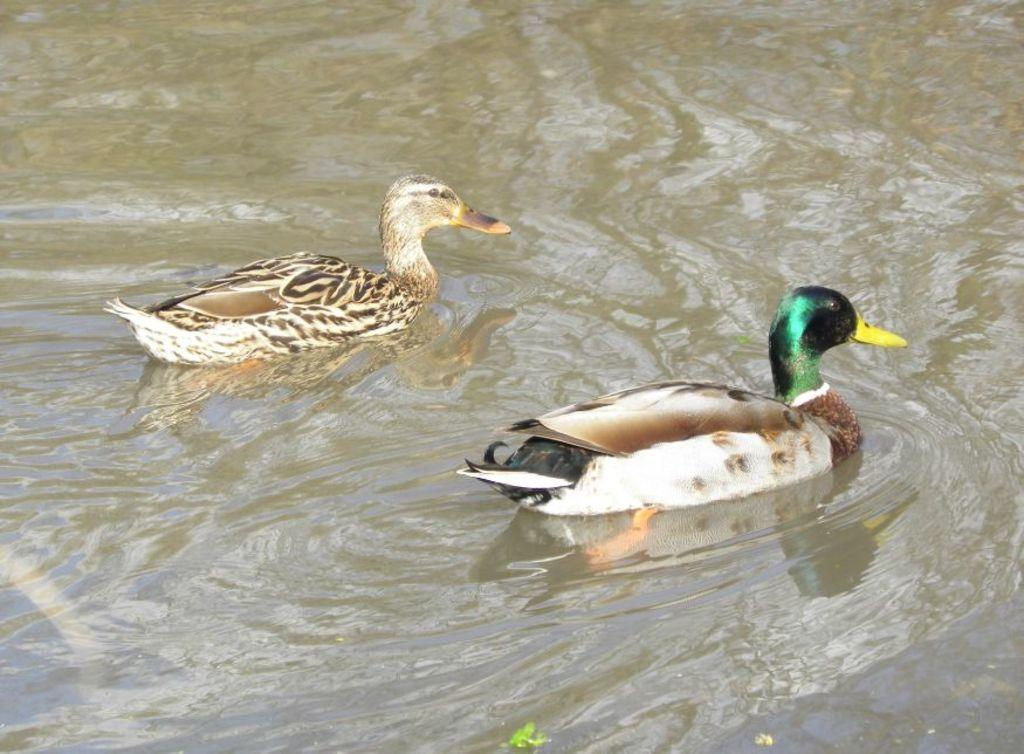What type of animals can be seen in the image? There are ducks in the image. Where are the ducks located? The ducks are present in the water. What type of fruit is floating in the water with the ducks? There is no fruit present in the image; it only features ducks in the water. 